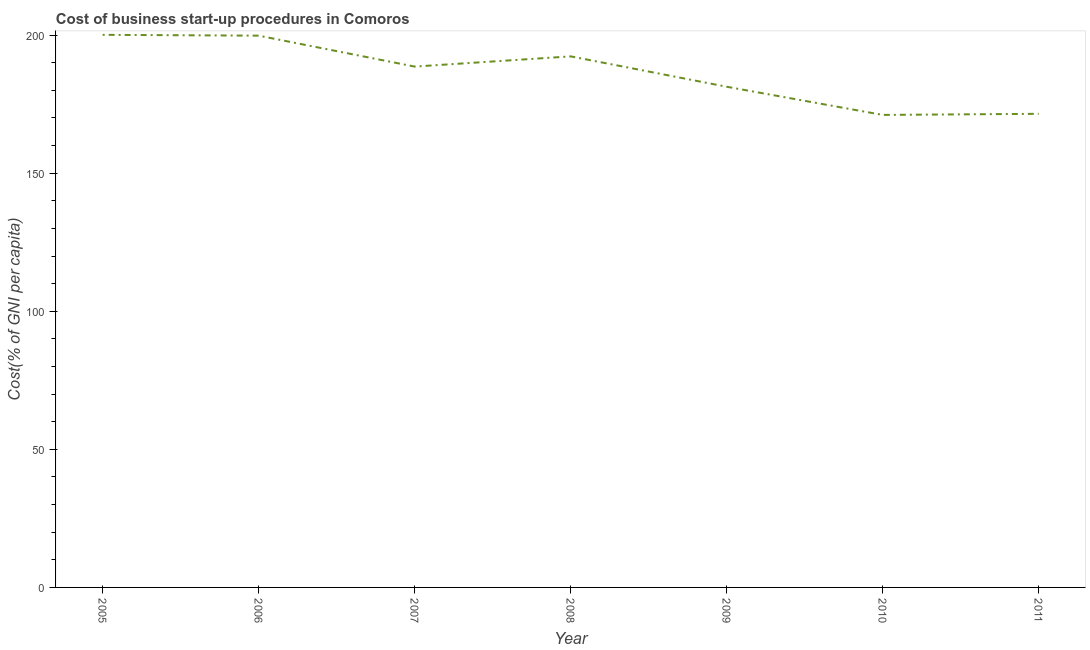What is the cost of business startup procedures in 2007?
Offer a very short reply. 188.6. Across all years, what is the maximum cost of business startup procedures?
Your answer should be compact. 200.1. Across all years, what is the minimum cost of business startup procedures?
Your response must be concise. 171.1. What is the sum of the cost of business startup procedures?
Provide a short and direct response. 1304.7. What is the difference between the cost of business startup procedures in 2008 and 2009?
Your answer should be compact. 11. What is the average cost of business startup procedures per year?
Make the answer very short. 186.39. What is the median cost of business startup procedures?
Offer a terse response. 188.6. What is the ratio of the cost of business startup procedures in 2005 to that in 2007?
Ensure brevity in your answer.  1.06. What is the difference between the highest and the second highest cost of business startup procedures?
Provide a short and direct response. 0.3. How many years are there in the graph?
Keep it short and to the point. 7. What is the title of the graph?
Your answer should be very brief. Cost of business start-up procedures in Comoros. What is the label or title of the X-axis?
Offer a terse response. Year. What is the label or title of the Y-axis?
Offer a very short reply. Cost(% of GNI per capita). What is the Cost(% of GNI per capita) of 2005?
Provide a short and direct response. 200.1. What is the Cost(% of GNI per capita) of 2006?
Make the answer very short. 199.8. What is the Cost(% of GNI per capita) of 2007?
Offer a terse response. 188.6. What is the Cost(% of GNI per capita) in 2008?
Offer a very short reply. 192.3. What is the Cost(% of GNI per capita) in 2009?
Give a very brief answer. 181.3. What is the Cost(% of GNI per capita) of 2010?
Ensure brevity in your answer.  171.1. What is the Cost(% of GNI per capita) of 2011?
Your answer should be very brief. 171.5. What is the difference between the Cost(% of GNI per capita) in 2005 and 2006?
Provide a short and direct response. 0.3. What is the difference between the Cost(% of GNI per capita) in 2005 and 2007?
Provide a succinct answer. 11.5. What is the difference between the Cost(% of GNI per capita) in 2005 and 2008?
Make the answer very short. 7.8. What is the difference between the Cost(% of GNI per capita) in 2005 and 2009?
Keep it short and to the point. 18.8. What is the difference between the Cost(% of GNI per capita) in 2005 and 2010?
Give a very brief answer. 29. What is the difference between the Cost(% of GNI per capita) in 2005 and 2011?
Your response must be concise. 28.6. What is the difference between the Cost(% of GNI per capita) in 2006 and 2007?
Offer a terse response. 11.2. What is the difference between the Cost(% of GNI per capita) in 2006 and 2008?
Your answer should be compact. 7.5. What is the difference between the Cost(% of GNI per capita) in 2006 and 2009?
Your response must be concise. 18.5. What is the difference between the Cost(% of GNI per capita) in 2006 and 2010?
Keep it short and to the point. 28.7. What is the difference between the Cost(% of GNI per capita) in 2006 and 2011?
Your answer should be compact. 28.3. What is the difference between the Cost(% of GNI per capita) in 2007 and 2008?
Offer a terse response. -3.7. What is the difference between the Cost(% of GNI per capita) in 2007 and 2011?
Make the answer very short. 17.1. What is the difference between the Cost(% of GNI per capita) in 2008 and 2010?
Offer a terse response. 21.2. What is the difference between the Cost(% of GNI per capita) in 2008 and 2011?
Give a very brief answer. 20.8. What is the difference between the Cost(% of GNI per capita) in 2010 and 2011?
Provide a short and direct response. -0.4. What is the ratio of the Cost(% of GNI per capita) in 2005 to that in 2006?
Your response must be concise. 1. What is the ratio of the Cost(% of GNI per capita) in 2005 to that in 2007?
Offer a very short reply. 1.06. What is the ratio of the Cost(% of GNI per capita) in 2005 to that in 2008?
Your answer should be very brief. 1.04. What is the ratio of the Cost(% of GNI per capita) in 2005 to that in 2009?
Keep it short and to the point. 1.1. What is the ratio of the Cost(% of GNI per capita) in 2005 to that in 2010?
Offer a terse response. 1.17. What is the ratio of the Cost(% of GNI per capita) in 2005 to that in 2011?
Offer a very short reply. 1.17. What is the ratio of the Cost(% of GNI per capita) in 2006 to that in 2007?
Provide a short and direct response. 1.06. What is the ratio of the Cost(% of GNI per capita) in 2006 to that in 2008?
Offer a terse response. 1.04. What is the ratio of the Cost(% of GNI per capita) in 2006 to that in 2009?
Your response must be concise. 1.1. What is the ratio of the Cost(% of GNI per capita) in 2006 to that in 2010?
Keep it short and to the point. 1.17. What is the ratio of the Cost(% of GNI per capita) in 2006 to that in 2011?
Provide a succinct answer. 1.17. What is the ratio of the Cost(% of GNI per capita) in 2007 to that in 2009?
Your response must be concise. 1.04. What is the ratio of the Cost(% of GNI per capita) in 2007 to that in 2010?
Provide a succinct answer. 1.1. What is the ratio of the Cost(% of GNI per capita) in 2008 to that in 2009?
Your answer should be compact. 1.06. What is the ratio of the Cost(% of GNI per capita) in 2008 to that in 2010?
Provide a short and direct response. 1.12. What is the ratio of the Cost(% of GNI per capita) in 2008 to that in 2011?
Make the answer very short. 1.12. What is the ratio of the Cost(% of GNI per capita) in 2009 to that in 2010?
Your answer should be very brief. 1.06. What is the ratio of the Cost(% of GNI per capita) in 2009 to that in 2011?
Give a very brief answer. 1.06. 